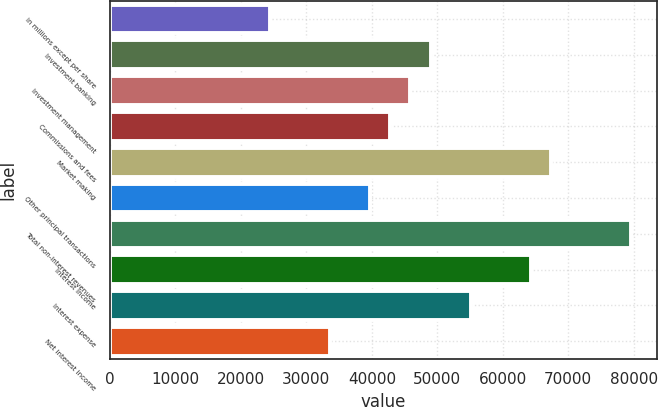<chart> <loc_0><loc_0><loc_500><loc_500><bar_chart><fcel>in millions except per share<fcel>Investment banking<fcel>Investment management<fcel>Commissions and fees<fcel>Market making<fcel>Other principal transactions<fcel>Total non-interest revenues<fcel>Interest income<fcel>Interest expense<fcel>Net interest income<nl><fcel>24489.7<fcel>48963<fcel>45903.8<fcel>42844.7<fcel>67318<fcel>39785.5<fcel>79554.7<fcel>64258.9<fcel>55081.3<fcel>33667.2<nl></chart> 